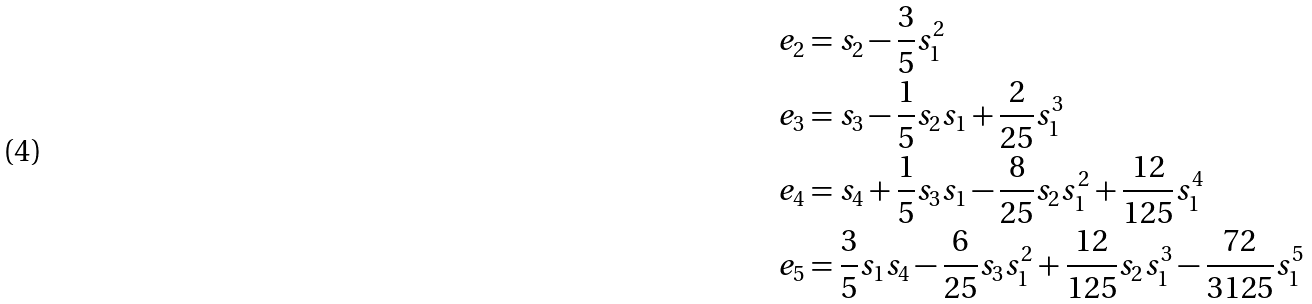<formula> <loc_0><loc_0><loc_500><loc_500>\ e _ { 2 } & = s _ { 2 } - \frac { 3 } { 5 } s _ { 1 } ^ { 2 } \\ \ e _ { 3 } & = s _ { 3 } - \frac { 1 } { 5 } s _ { 2 } s _ { 1 } + \frac { 2 } { 2 5 } s _ { 1 } ^ { 3 } \\ \ e _ { 4 } & = s _ { 4 } + \frac { 1 } { 5 } s _ { 3 } s _ { 1 } - \frac { 8 } { 2 5 } s _ { 2 } s _ { 1 } ^ { 2 } + \frac { 1 2 } { 1 2 5 } s _ { 1 } ^ { 4 } \\ \ e _ { 5 } & = \frac { 3 } { 5 } s _ { 1 } s _ { 4 } - \frac { 6 } { 2 5 } s _ { 3 } s _ { 1 } ^ { 2 } + \frac { 1 2 } { 1 2 5 } s _ { 2 } s _ { 1 } ^ { 3 } - \frac { 7 2 } { 3 1 2 5 } s _ { 1 } ^ { 5 }</formula> 